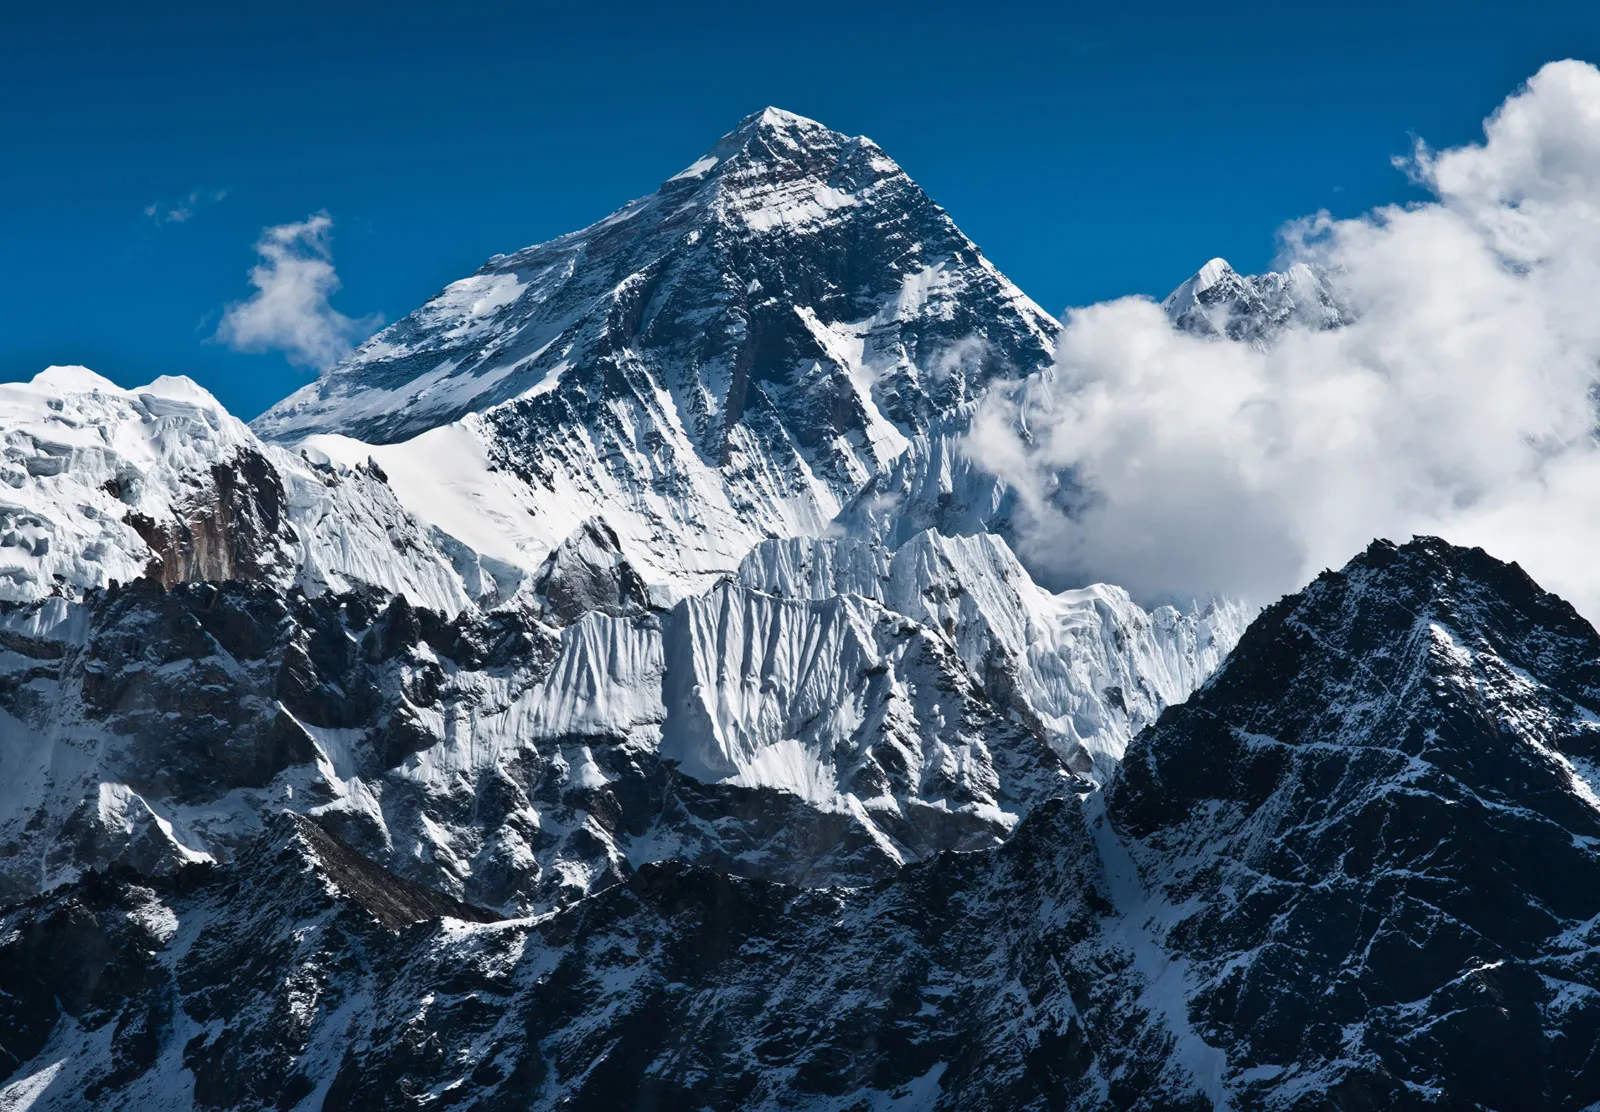What are the typical weather conditions around Mount Everest, and how do they affect climbing expeditions? The weather conditions on Mount Everest are notoriously harsh and unpredictable. Temperatures can drop below -60 degrees Celsius in winter and average around -19 degrees Celsius in the summertime at the summit. The mountain is also prone to sudden severe snowstorms and winds that can exceed 200 km/h. These extreme conditions make climbing Everest both challenging and dangerous, limiting expeditions to two main seasons, pre-monsoon (late April to early June) and post-monsoon (late September to October) when the weather is relatively more stable. 